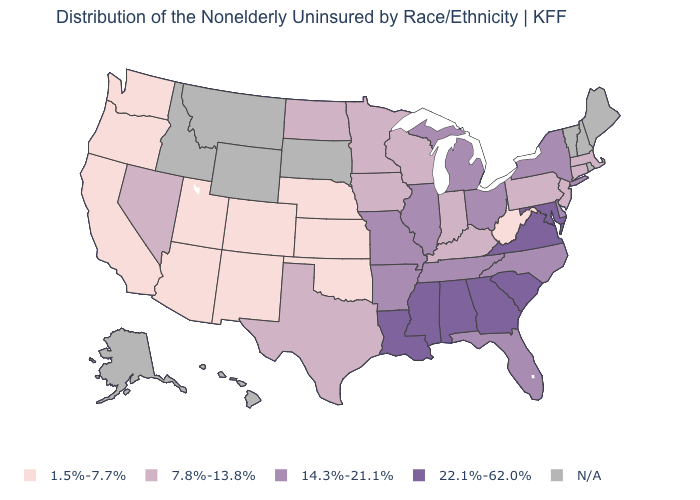Which states hav the highest value in the South?
Short answer required. Alabama, Georgia, Louisiana, Maryland, Mississippi, South Carolina, Virginia. What is the value of Hawaii?
Answer briefly. N/A. What is the value of Oregon?
Give a very brief answer. 1.5%-7.7%. What is the value of North Dakota?
Answer briefly. 7.8%-13.8%. What is the lowest value in the USA?
Answer briefly. 1.5%-7.7%. Does New Jersey have the lowest value in the Northeast?
Be succinct. Yes. Among the states that border South Carolina , does Georgia have the lowest value?
Give a very brief answer. No. What is the lowest value in the USA?
Give a very brief answer. 1.5%-7.7%. Among the states that border Massachusetts , which have the highest value?
Keep it brief. New York. What is the value of Georgia?
Keep it brief. 22.1%-62.0%. Does Pennsylvania have the lowest value in the USA?
Write a very short answer. No. Among the states that border North Dakota , which have the highest value?
Keep it brief. Minnesota. What is the value of Louisiana?
Quick response, please. 22.1%-62.0%. Which states have the highest value in the USA?
Short answer required. Alabama, Georgia, Louisiana, Maryland, Mississippi, South Carolina, Virginia. 